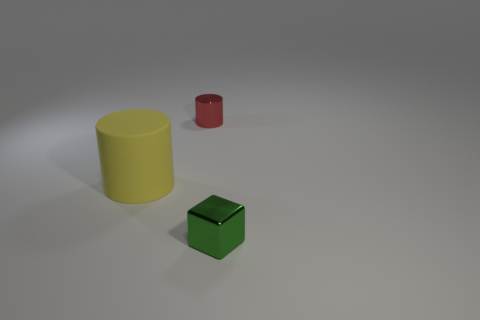What could the setting of this image imply? The setting shown in the image appears to be a neutral studio environment with soft, diffuse lighting and a simple, uncluttered background. This controlled setting likely suggests that the focus is meant to be on the objects themselves, possibly for a product presentation, a visual experiment, or an educational purpose to clearly showcase the shape and color of the objects without any distractions. 